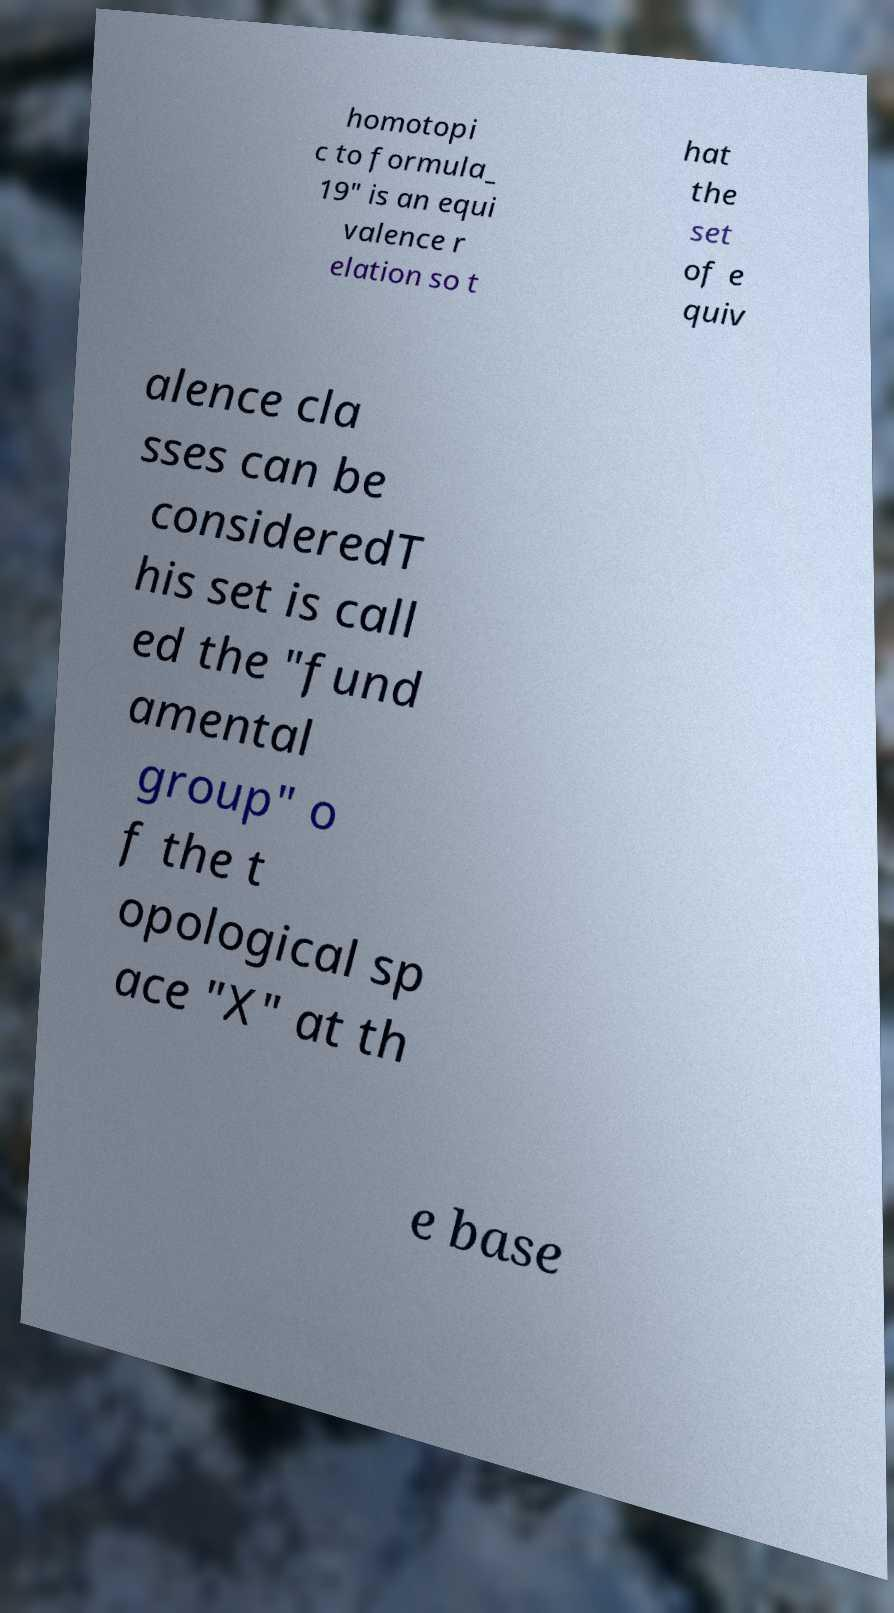Could you extract and type out the text from this image? homotopi c to formula_ 19" is an equi valence r elation so t hat the set of e quiv alence cla sses can be consideredT his set is call ed the "fund amental group" o f the t opological sp ace "X" at th e base 